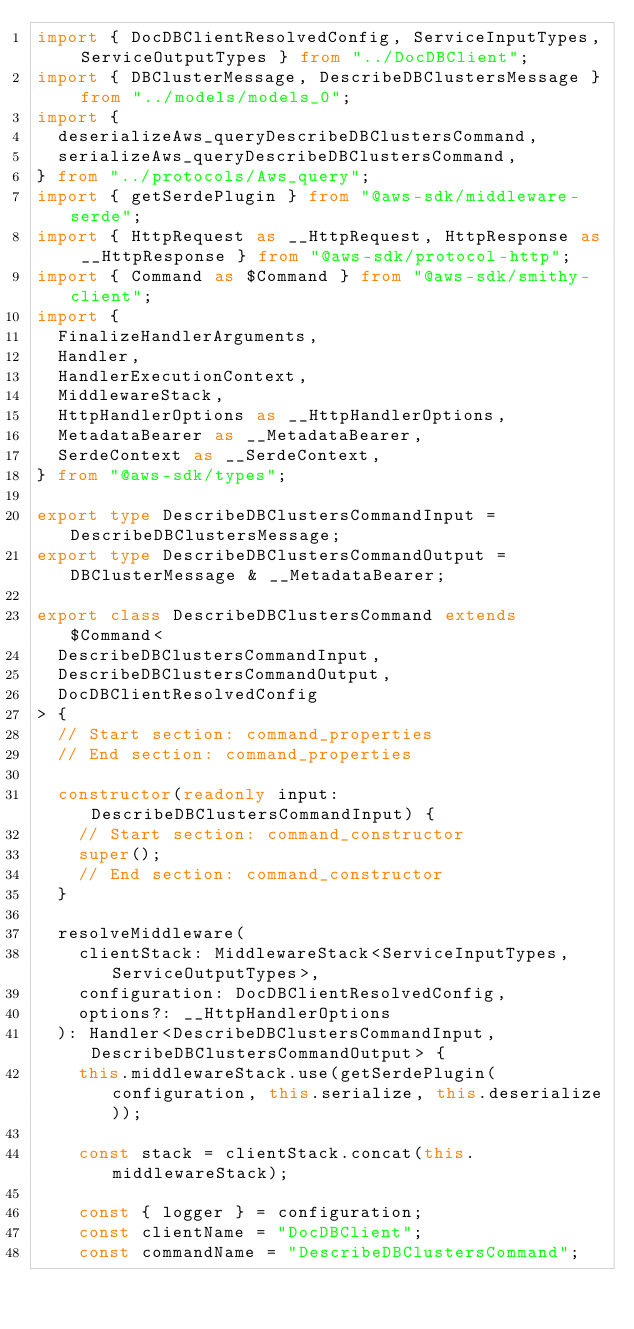Convert code to text. <code><loc_0><loc_0><loc_500><loc_500><_TypeScript_>import { DocDBClientResolvedConfig, ServiceInputTypes, ServiceOutputTypes } from "../DocDBClient";
import { DBClusterMessage, DescribeDBClustersMessage } from "../models/models_0";
import {
  deserializeAws_queryDescribeDBClustersCommand,
  serializeAws_queryDescribeDBClustersCommand,
} from "../protocols/Aws_query";
import { getSerdePlugin } from "@aws-sdk/middleware-serde";
import { HttpRequest as __HttpRequest, HttpResponse as __HttpResponse } from "@aws-sdk/protocol-http";
import { Command as $Command } from "@aws-sdk/smithy-client";
import {
  FinalizeHandlerArguments,
  Handler,
  HandlerExecutionContext,
  MiddlewareStack,
  HttpHandlerOptions as __HttpHandlerOptions,
  MetadataBearer as __MetadataBearer,
  SerdeContext as __SerdeContext,
} from "@aws-sdk/types";

export type DescribeDBClustersCommandInput = DescribeDBClustersMessage;
export type DescribeDBClustersCommandOutput = DBClusterMessage & __MetadataBearer;

export class DescribeDBClustersCommand extends $Command<
  DescribeDBClustersCommandInput,
  DescribeDBClustersCommandOutput,
  DocDBClientResolvedConfig
> {
  // Start section: command_properties
  // End section: command_properties

  constructor(readonly input: DescribeDBClustersCommandInput) {
    // Start section: command_constructor
    super();
    // End section: command_constructor
  }

  resolveMiddleware(
    clientStack: MiddlewareStack<ServiceInputTypes, ServiceOutputTypes>,
    configuration: DocDBClientResolvedConfig,
    options?: __HttpHandlerOptions
  ): Handler<DescribeDBClustersCommandInput, DescribeDBClustersCommandOutput> {
    this.middlewareStack.use(getSerdePlugin(configuration, this.serialize, this.deserialize));

    const stack = clientStack.concat(this.middlewareStack);

    const { logger } = configuration;
    const clientName = "DocDBClient";
    const commandName = "DescribeDBClustersCommand";</code> 